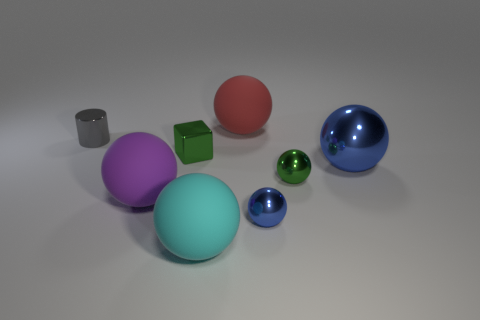There is a small metal block; how many large things are in front of it?
Offer a very short reply. 3. What is the color of the big metal thing that is the same shape as the purple matte thing?
Your answer should be very brief. Blue. Does the big sphere that is behind the small metallic cylinder have the same material as the small thing that is left of the metallic cube?
Make the answer very short. No. There is a metallic cube; does it have the same color as the large rubber ball behind the big metal object?
Offer a terse response. No. What shape is the thing that is behind the cube and to the right of the tiny gray metallic cylinder?
Provide a succinct answer. Sphere. What number of tiny cylinders are there?
Provide a succinct answer. 1. The object that is the same color as the metallic cube is what shape?
Ensure brevity in your answer.  Sphere. There is a purple thing that is the same shape as the cyan thing; what is its size?
Ensure brevity in your answer.  Large. There is a metal object to the left of the green metallic cube; does it have the same shape as the big blue metallic object?
Ensure brevity in your answer.  No. The large ball that is behind the big metallic object is what color?
Give a very brief answer. Red. 